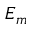Convert formula to latex. <formula><loc_0><loc_0><loc_500><loc_500>E _ { m }</formula> 